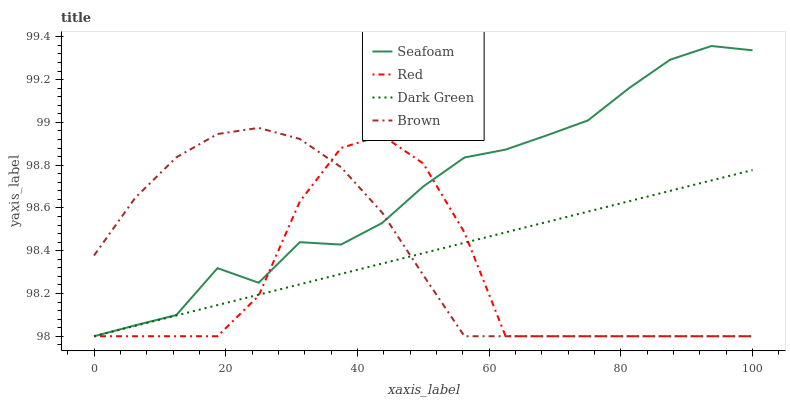Does Red have the minimum area under the curve?
Answer yes or no. Yes. Does Seafoam have the maximum area under the curve?
Answer yes or no. Yes. Does Seafoam have the minimum area under the curve?
Answer yes or no. No. Does Red have the maximum area under the curve?
Answer yes or no. No. Is Dark Green the smoothest?
Answer yes or no. Yes. Is Red the roughest?
Answer yes or no. Yes. Is Seafoam the smoothest?
Answer yes or no. No. Is Seafoam the roughest?
Answer yes or no. No. Does Brown have the lowest value?
Answer yes or no. Yes. Does Seafoam have the highest value?
Answer yes or no. Yes. Does Red have the highest value?
Answer yes or no. No. Does Brown intersect Red?
Answer yes or no. Yes. Is Brown less than Red?
Answer yes or no. No. Is Brown greater than Red?
Answer yes or no. No. 